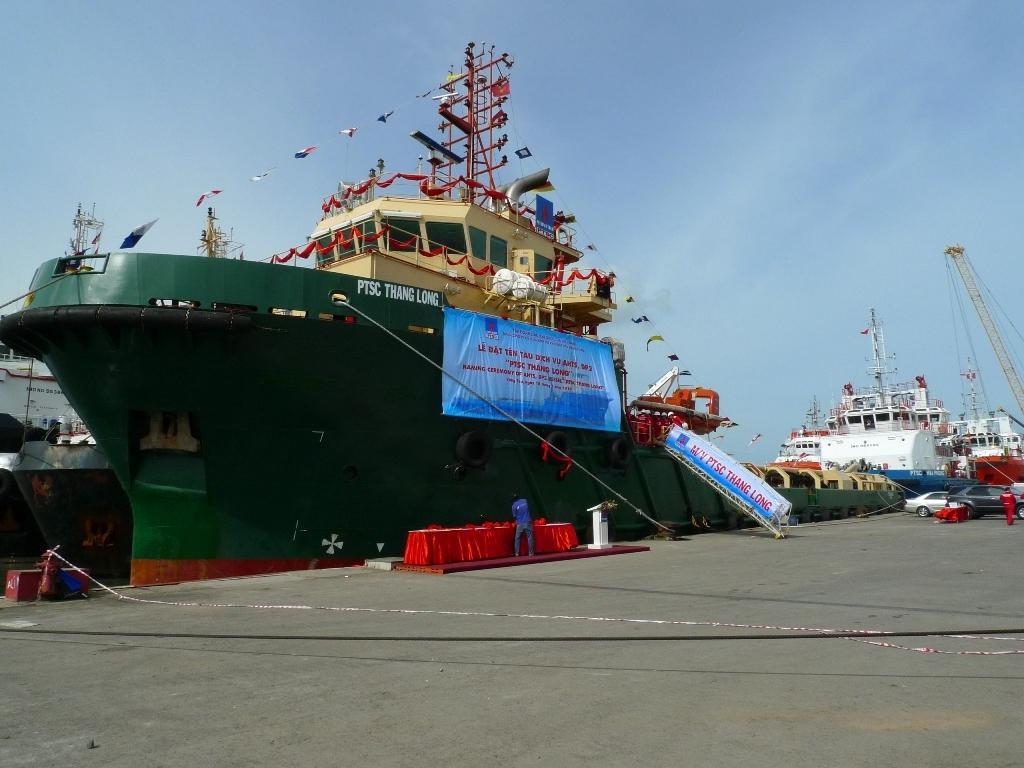Please provide a concise description of this image. In this image I can see there is a big ship in green color. There are banners on it, on the right side there are white color ships and also there are cars that are parked on the road. At the top it is the blue color sky. 